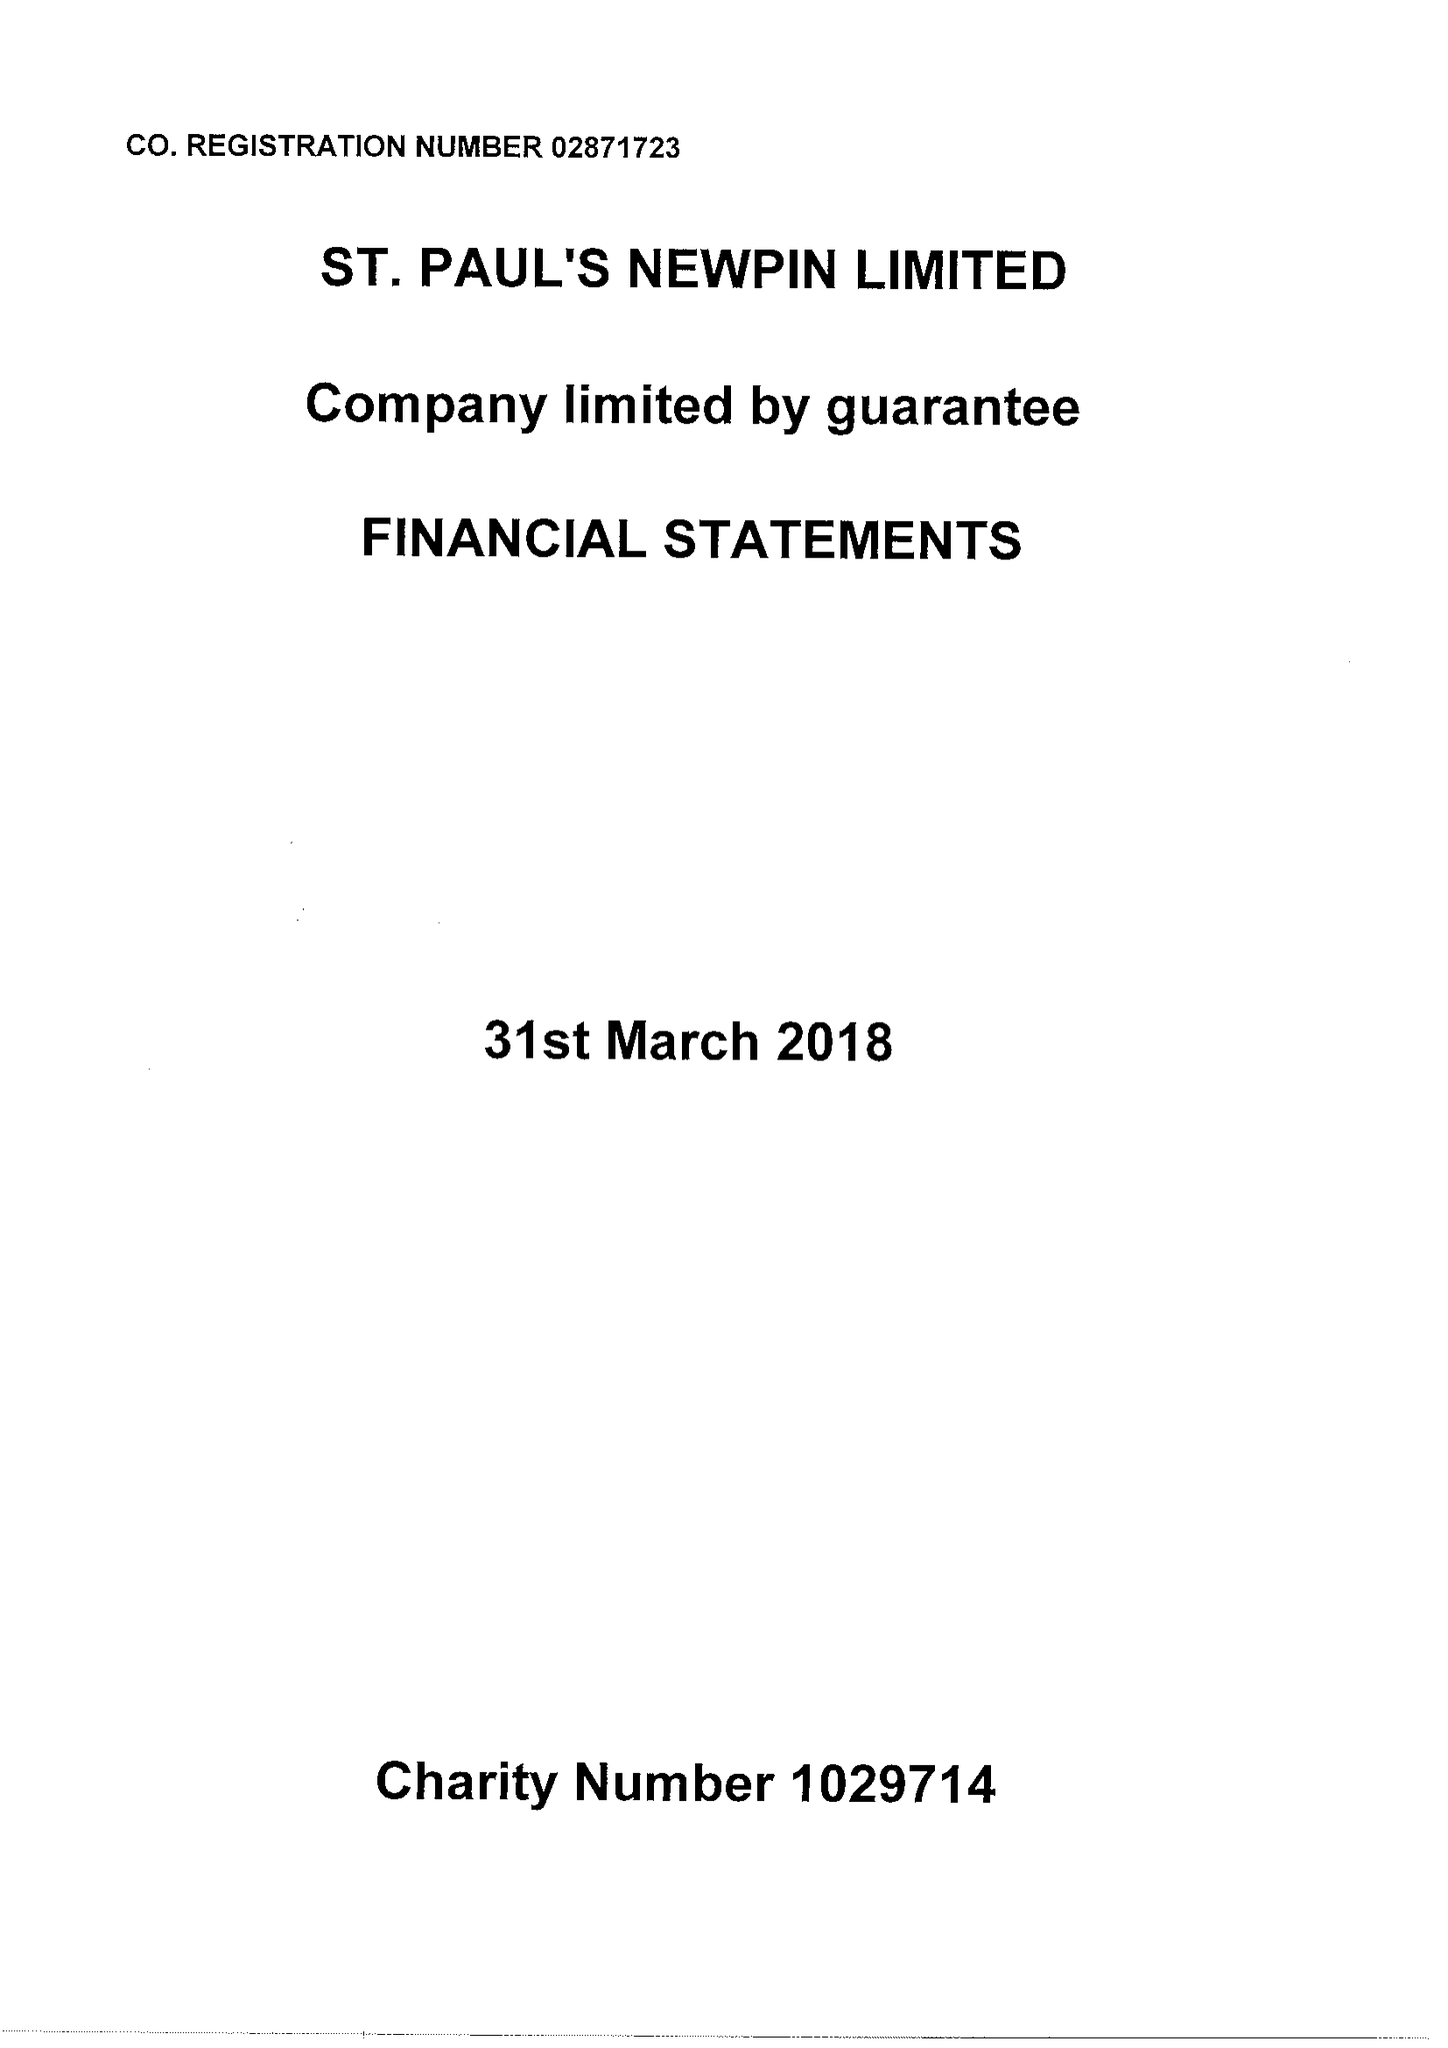What is the value for the address__postcode?
Answer the question using a single word or phrase. NW8 8EQ 